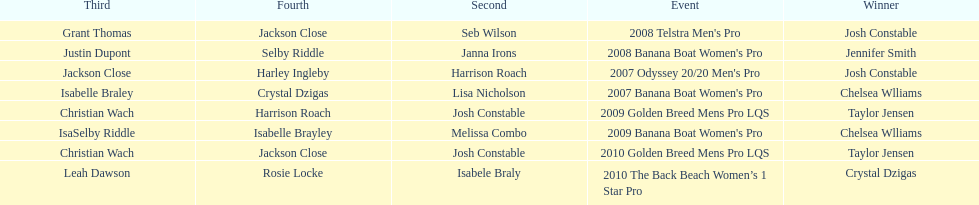Who was the top performer in the 2008 telstra men's pro? Josh Constable. 